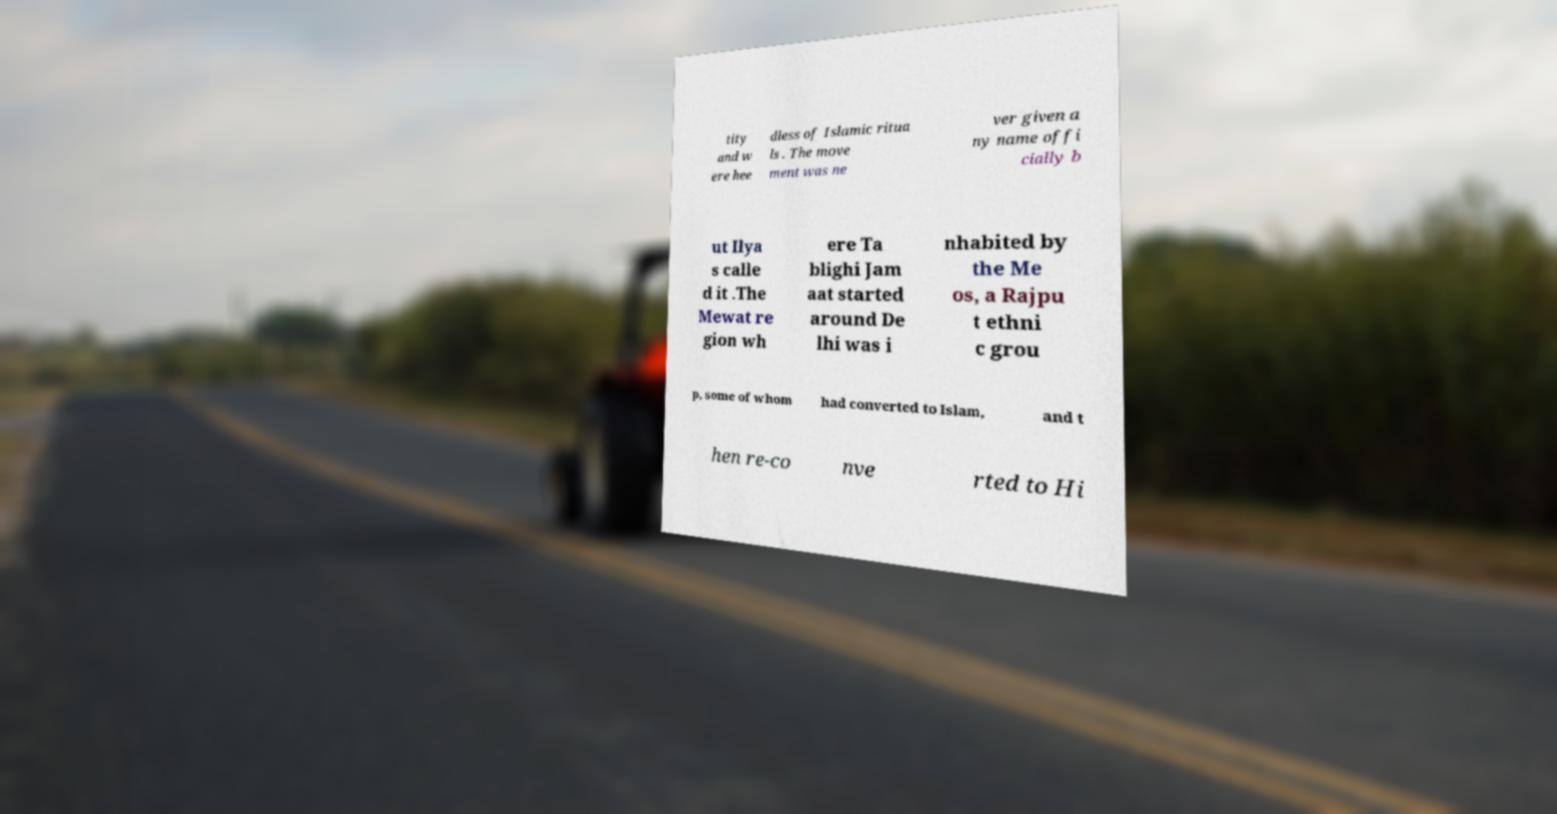Can you read and provide the text displayed in the image?This photo seems to have some interesting text. Can you extract and type it out for me? tity and w ere hee dless of Islamic ritua ls . The move ment was ne ver given a ny name offi cially b ut Ilya s calle d it .The Mewat re gion wh ere Ta blighi Jam aat started around De lhi was i nhabited by the Me os, a Rajpu t ethni c grou p, some of whom had converted to Islam, and t hen re-co nve rted to Hi 